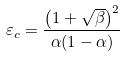Convert formula to latex. <formula><loc_0><loc_0><loc_500><loc_500>\varepsilon _ { c } = \frac { \left ( 1 + \sqrt { \beta } \right ) ^ { 2 } } { \alpha ( 1 - \alpha ) }</formula> 